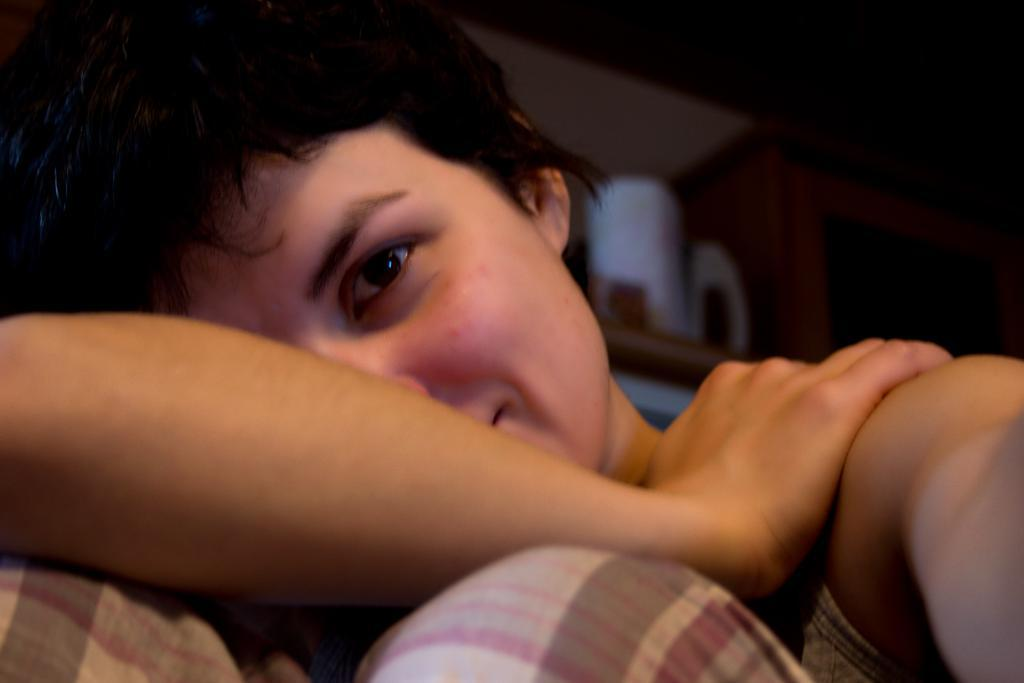What is the main subject in the center of the image? There is a person in the center of the image. Can you describe the background of the image? There are objects in the background of the image. What type of brass engine can be seen in the image? There is no brass engine present in the image. 